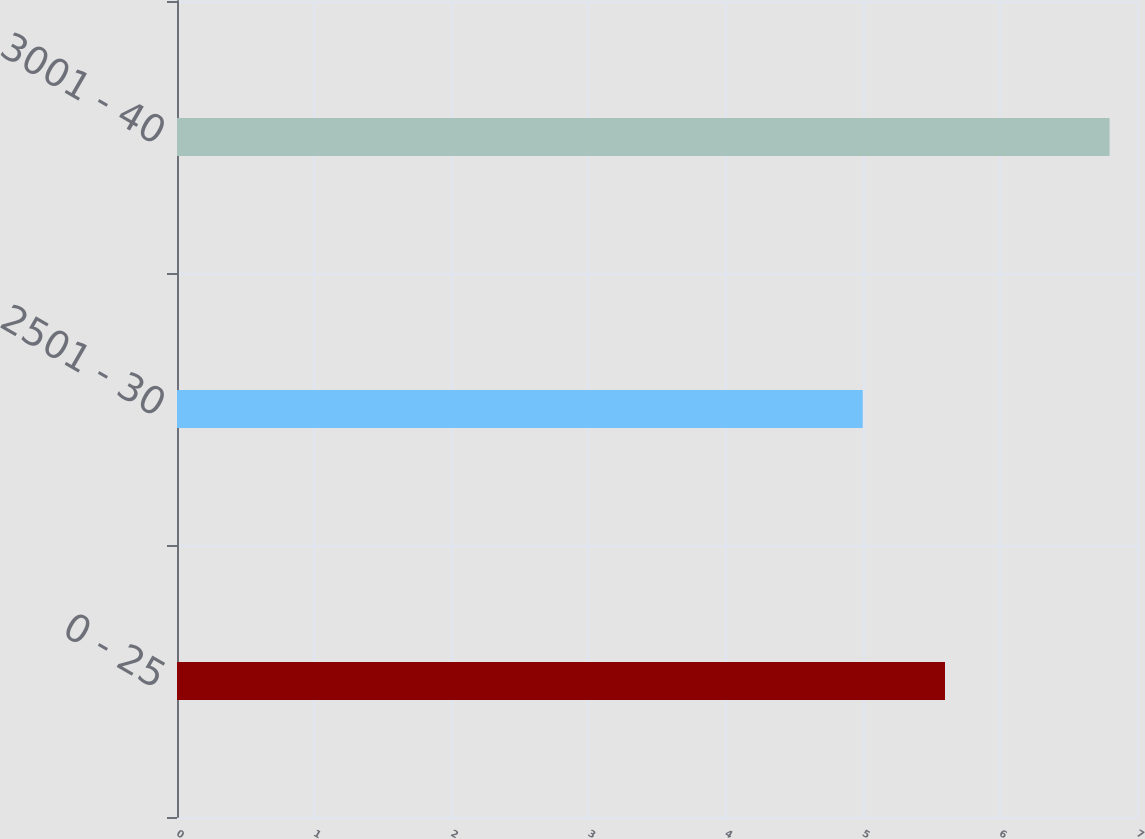Convert chart. <chart><loc_0><loc_0><loc_500><loc_500><bar_chart><fcel>0 - 25<fcel>2501 - 30<fcel>3001 - 40<nl><fcel>5.6<fcel>5<fcel>6.8<nl></chart> 